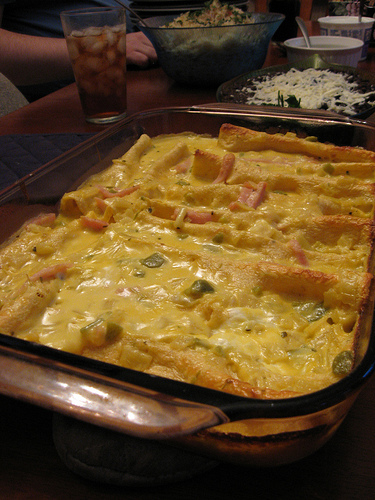<image>
Is the glass behind the food? Yes. From this viewpoint, the glass is positioned behind the food, with the food partially or fully occluding the glass. 